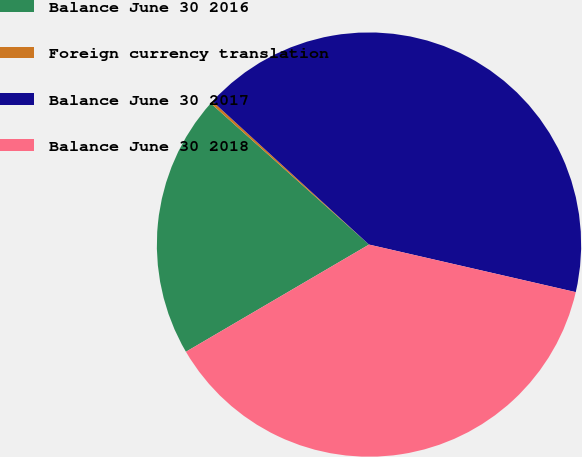<chart> <loc_0><loc_0><loc_500><loc_500><pie_chart><fcel>Balance June 30 2016<fcel>Foreign currency translation<fcel>Balance June 30 2017<fcel>Balance June 30 2018<nl><fcel>20.03%<fcel>0.2%<fcel>41.8%<fcel>37.97%<nl></chart> 